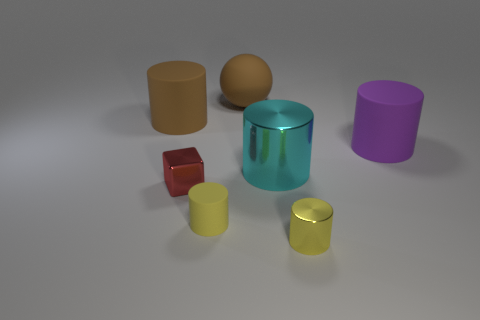The large rubber cylinder that is on the right side of the large object that is behind the matte thing that is left of the tiny cube is what color?
Offer a terse response. Purple. What is the shape of the big object that is on the right side of the matte sphere and behind the large metallic object?
Your answer should be compact. Cylinder. What number of other things are there of the same shape as the small matte object?
Provide a succinct answer. 4. The big brown thing behind the rubber cylinder that is to the left of the yellow object to the left of the brown ball is what shape?
Give a very brief answer. Sphere. What number of objects are large cylinders or big things in front of the sphere?
Make the answer very short. 3. There is a big cyan thing right of the small yellow matte cylinder; does it have the same shape as the matte object that is on the right side of the large brown matte ball?
Offer a terse response. Yes. How many objects are either large purple blocks or yellow cylinders?
Keep it short and to the point. 2. Is there anything else that has the same material as the cyan cylinder?
Provide a short and direct response. Yes. Are there any big blue matte objects?
Provide a short and direct response. No. Is the material of the large thing behind the big brown rubber cylinder the same as the purple cylinder?
Ensure brevity in your answer.  Yes. 